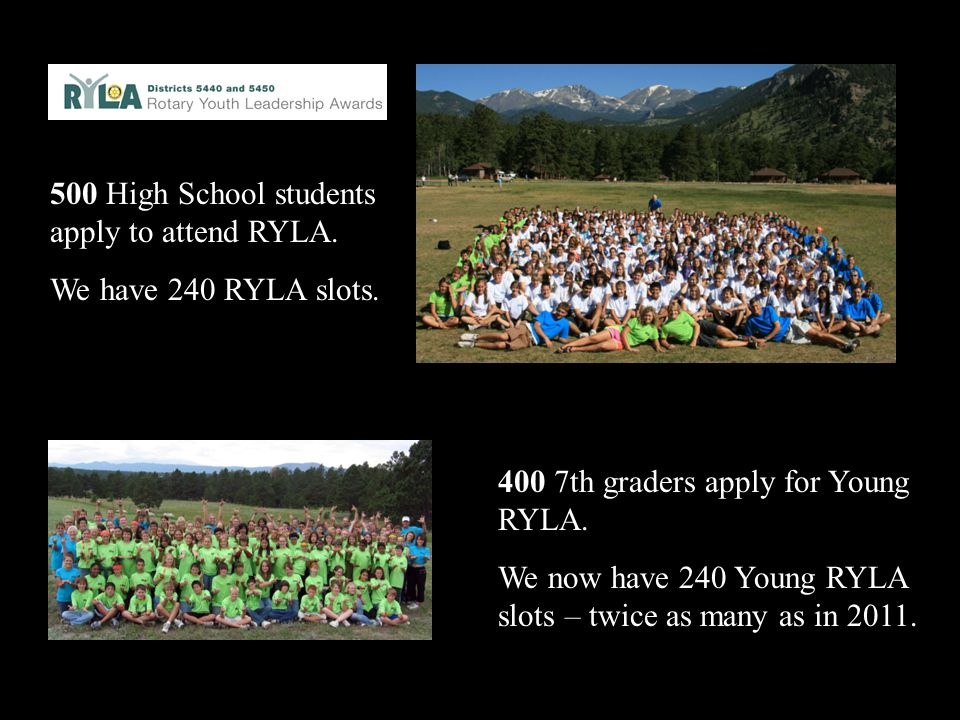What might be the significance of the increase in slots for the Young RYLA program compared to 2011? The increase in slots for the Young RYLA program, as shown in the image, represents a substantial enhancement in the program's capacity to serve aspiring youth leaders. This growth likely indicates a few key factors: a rise in the program's popularity and recognition, attracting more applicants; a strategic initiative by RYLA to expand its impact on youth by offering more opportunities; and possibly strong positive outcomes from past participants that have encouraged further investment. The doubling of slots from 2011 showcases the organizers' commitment to fostering youth leadership and the support they receive from stakeholders, highlighting the program's proven value and success. 